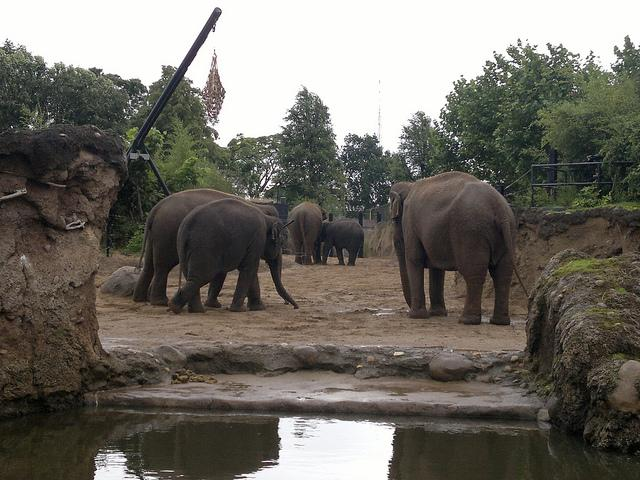What measurement is closest to the weight of the biggest animal here? Please explain your reasoning. 5 milligrams. An elephant weighs about four tons. a ton is 2000 pounds. 